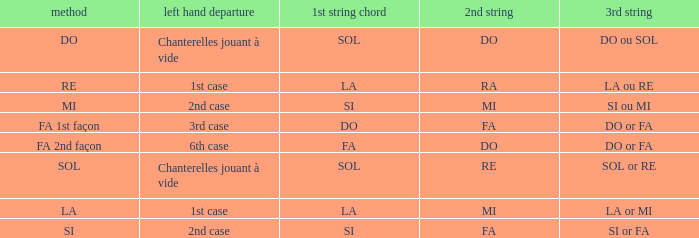What is the Depart de la main gauche of the do Mode? Chanterelles jouant à vide. 